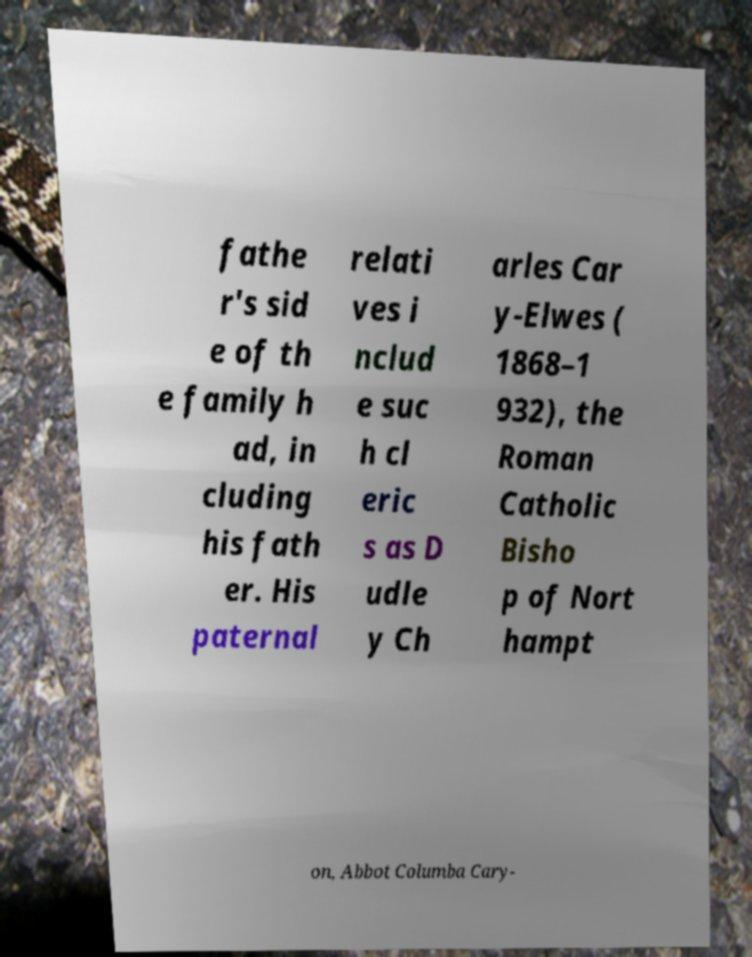I need the written content from this picture converted into text. Can you do that? fathe r's sid e of th e family h ad, in cluding his fath er. His paternal relati ves i nclud e suc h cl eric s as D udle y Ch arles Car y-Elwes ( 1868–1 932), the Roman Catholic Bisho p of Nort hampt on, Abbot Columba Cary- 